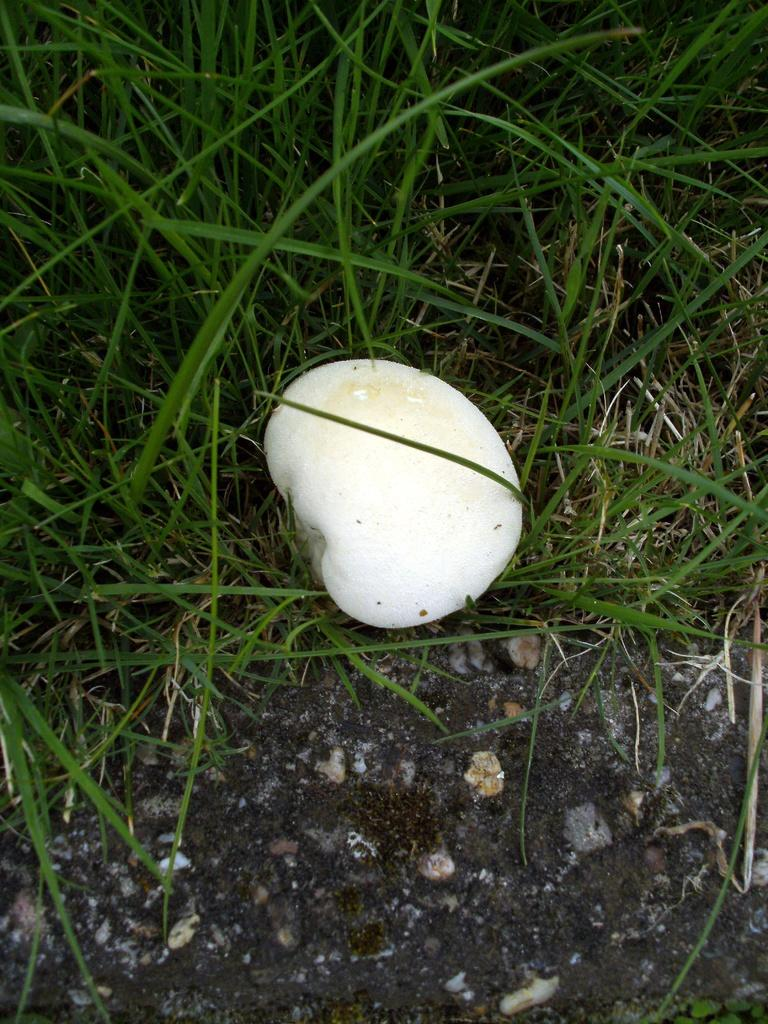What type of plant can be seen on the ground in the image? There is a mushroom on the ground in the image. What type of vegetation is present in the image? There is grass in the image. What type of government is depicted in the image? There is no depiction of a government in the image; it features a mushroom and grass. What is the mushroom using to water the grass in the image? There is no hose or any other watering device present in the image. 